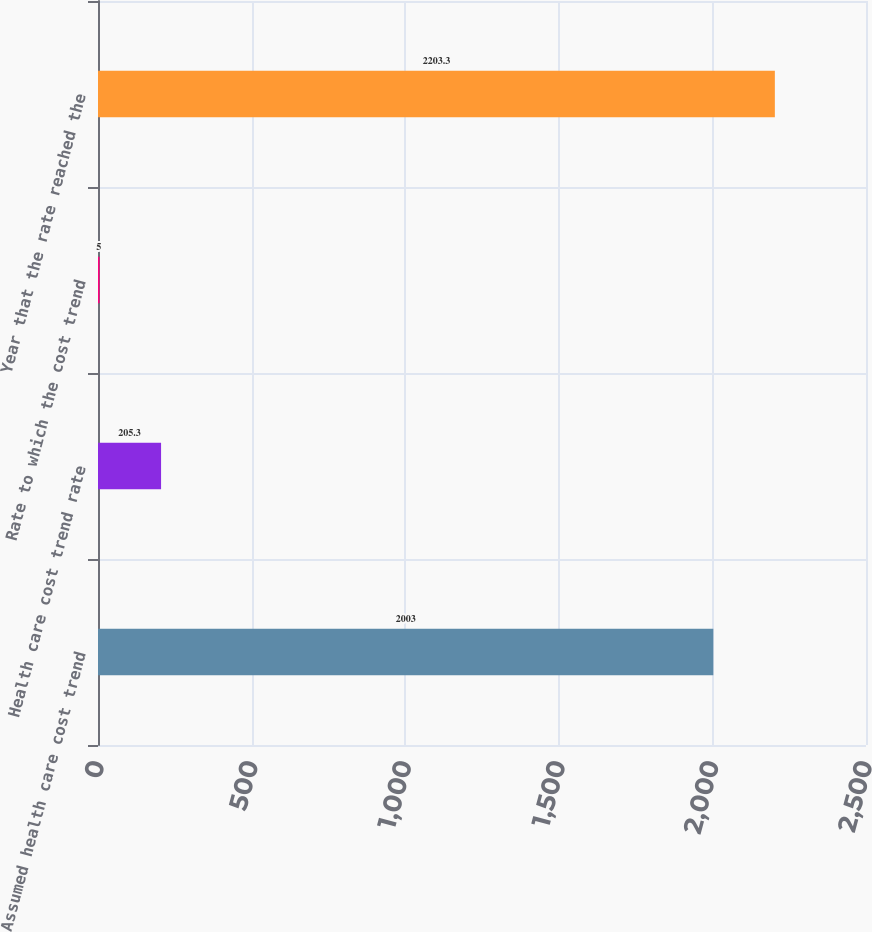<chart> <loc_0><loc_0><loc_500><loc_500><bar_chart><fcel>Assumed health care cost trend<fcel>Health care cost trend rate<fcel>Rate to which the cost trend<fcel>Year that the rate reached the<nl><fcel>2003<fcel>205.3<fcel>5<fcel>2203.3<nl></chart> 